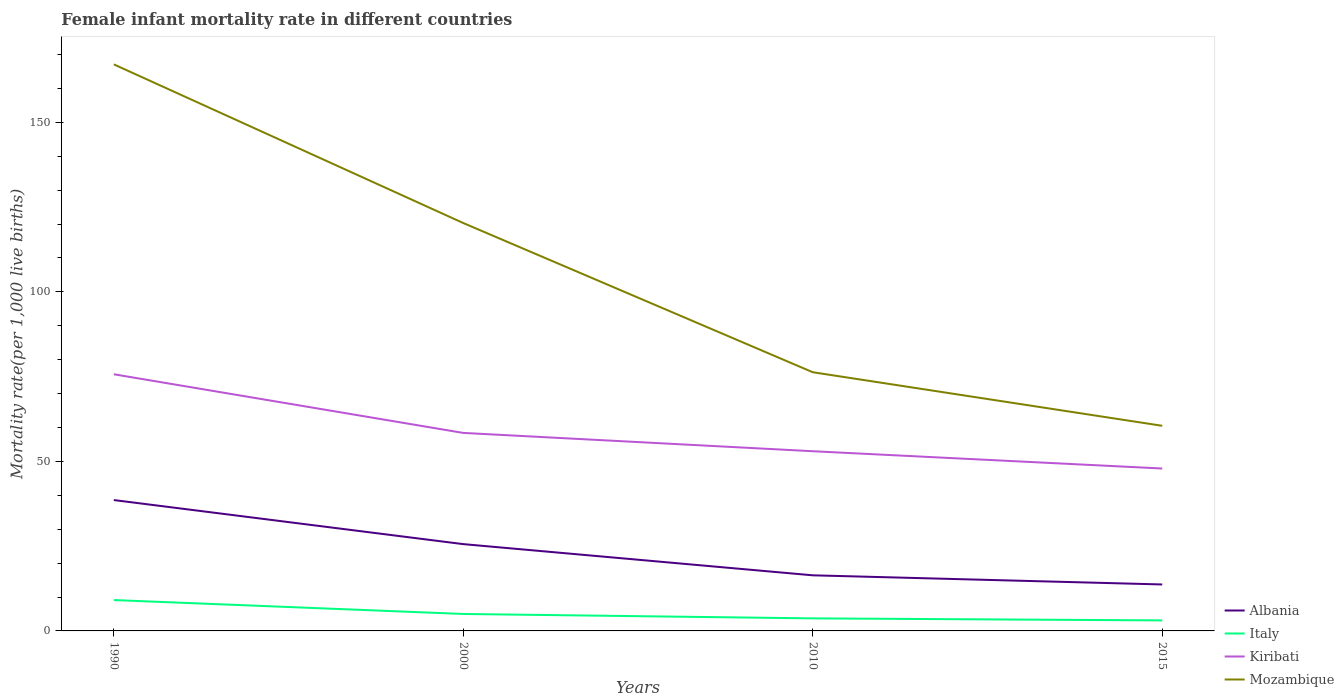How many different coloured lines are there?
Make the answer very short. 4. Does the line corresponding to Albania intersect with the line corresponding to Kiribati?
Offer a very short reply. No. Across all years, what is the maximum female infant mortality rate in Kiribati?
Keep it short and to the point. 47.9. In which year was the female infant mortality rate in Albania maximum?
Make the answer very short. 2015. What is the total female infant mortality rate in Mozambique in the graph?
Ensure brevity in your answer.  106.6. What is the difference between the highest and the second highest female infant mortality rate in Mozambique?
Offer a terse response. 106.6. What is the difference between the highest and the lowest female infant mortality rate in Mozambique?
Your answer should be compact. 2. Is the female infant mortality rate in Albania strictly greater than the female infant mortality rate in Kiribati over the years?
Your answer should be very brief. Yes. How many lines are there?
Make the answer very short. 4. What is the difference between two consecutive major ticks on the Y-axis?
Offer a terse response. 50. Does the graph contain any zero values?
Provide a succinct answer. No. How are the legend labels stacked?
Make the answer very short. Vertical. What is the title of the graph?
Your answer should be compact. Female infant mortality rate in different countries. Does "Sub-Saharan Africa (all income levels)" appear as one of the legend labels in the graph?
Your answer should be compact. No. What is the label or title of the Y-axis?
Make the answer very short. Mortality rate(per 1,0 live births). What is the Mortality rate(per 1,000 live births) of Albania in 1990?
Keep it short and to the point. 38.6. What is the Mortality rate(per 1,000 live births) of Kiribati in 1990?
Make the answer very short. 75.7. What is the Mortality rate(per 1,000 live births) in Mozambique in 1990?
Your answer should be very brief. 167.1. What is the Mortality rate(per 1,000 live births) in Albania in 2000?
Ensure brevity in your answer.  25.6. What is the Mortality rate(per 1,000 live births) of Italy in 2000?
Keep it short and to the point. 5. What is the Mortality rate(per 1,000 live births) in Kiribati in 2000?
Provide a short and direct response. 58.4. What is the Mortality rate(per 1,000 live births) of Mozambique in 2000?
Provide a short and direct response. 120.3. What is the Mortality rate(per 1,000 live births) in Albania in 2010?
Ensure brevity in your answer.  16.4. What is the Mortality rate(per 1,000 live births) of Mozambique in 2010?
Offer a very short reply. 76.3. What is the Mortality rate(per 1,000 live births) of Albania in 2015?
Make the answer very short. 13.7. What is the Mortality rate(per 1,000 live births) of Kiribati in 2015?
Provide a short and direct response. 47.9. What is the Mortality rate(per 1,000 live births) of Mozambique in 2015?
Provide a short and direct response. 60.5. Across all years, what is the maximum Mortality rate(per 1,000 live births) in Albania?
Provide a short and direct response. 38.6. Across all years, what is the maximum Mortality rate(per 1,000 live births) in Kiribati?
Make the answer very short. 75.7. Across all years, what is the maximum Mortality rate(per 1,000 live births) of Mozambique?
Keep it short and to the point. 167.1. Across all years, what is the minimum Mortality rate(per 1,000 live births) of Albania?
Give a very brief answer. 13.7. Across all years, what is the minimum Mortality rate(per 1,000 live births) of Kiribati?
Make the answer very short. 47.9. Across all years, what is the minimum Mortality rate(per 1,000 live births) of Mozambique?
Your response must be concise. 60.5. What is the total Mortality rate(per 1,000 live births) of Albania in the graph?
Offer a terse response. 94.3. What is the total Mortality rate(per 1,000 live births) of Italy in the graph?
Your response must be concise. 20.9. What is the total Mortality rate(per 1,000 live births) in Kiribati in the graph?
Your response must be concise. 235. What is the total Mortality rate(per 1,000 live births) in Mozambique in the graph?
Give a very brief answer. 424.2. What is the difference between the Mortality rate(per 1,000 live births) in Albania in 1990 and that in 2000?
Offer a terse response. 13. What is the difference between the Mortality rate(per 1,000 live births) in Kiribati in 1990 and that in 2000?
Ensure brevity in your answer.  17.3. What is the difference between the Mortality rate(per 1,000 live births) in Mozambique in 1990 and that in 2000?
Make the answer very short. 46.8. What is the difference between the Mortality rate(per 1,000 live births) in Italy in 1990 and that in 2010?
Your answer should be compact. 5.4. What is the difference between the Mortality rate(per 1,000 live births) in Kiribati in 1990 and that in 2010?
Offer a very short reply. 22.7. What is the difference between the Mortality rate(per 1,000 live births) in Mozambique in 1990 and that in 2010?
Your answer should be compact. 90.8. What is the difference between the Mortality rate(per 1,000 live births) in Albania in 1990 and that in 2015?
Provide a short and direct response. 24.9. What is the difference between the Mortality rate(per 1,000 live births) of Italy in 1990 and that in 2015?
Give a very brief answer. 6. What is the difference between the Mortality rate(per 1,000 live births) in Kiribati in 1990 and that in 2015?
Your answer should be compact. 27.8. What is the difference between the Mortality rate(per 1,000 live births) in Mozambique in 1990 and that in 2015?
Keep it short and to the point. 106.6. What is the difference between the Mortality rate(per 1,000 live births) of Kiribati in 2000 and that in 2010?
Ensure brevity in your answer.  5.4. What is the difference between the Mortality rate(per 1,000 live births) in Italy in 2000 and that in 2015?
Offer a very short reply. 1.9. What is the difference between the Mortality rate(per 1,000 live births) in Kiribati in 2000 and that in 2015?
Make the answer very short. 10.5. What is the difference between the Mortality rate(per 1,000 live births) in Mozambique in 2000 and that in 2015?
Provide a succinct answer. 59.8. What is the difference between the Mortality rate(per 1,000 live births) in Albania in 1990 and the Mortality rate(per 1,000 live births) in Italy in 2000?
Provide a short and direct response. 33.6. What is the difference between the Mortality rate(per 1,000 live births) of Albania in 1990 and the Mortality rate(per 1,000 live births) of Kiribati in 2000?
Your response must be concise. -19.8. What is the difference between the Mortality rate(per 1,000 live births) of Albania in 1990 and the Mortality rate(per 1,000 live births) of Mozambique in 2000?
Give a very brief answer. -81.7. What is the difference between the Mortality rate(per 1,000 live births) in Italy in 1990 and the Mortality rate(per 1,000 live births) in Kiribati in 2000?
Your answer should be compact. -49.3. What is the difference between the Mortality rate(per 1,000 live births) in Italy in 1990 and the Mortality rate(per 1,000 live births) in Mozambique in 2000?
Provide a succinct answer. -111.2. What is the difference between the Mortality rate(per 1,000 live births) of Kiribati in 1990 and the Mortality rate(per 1,000 live births) of Mozambique in 2000?
Provide a succinct answer. -44.6. What is the difference between the Mortality rate(per 1,000 live births) of Albania in 1990 and the Mortality rate(per 1,000 live births) of Italy in 2010?
Keep it short and to the point. 34.9. What is the difference between the Mortality rate(per 1,000 live births) of Albania in 1990 and the Mortality rate(per 1,000 live births) of Kiribati in 2010?
Your answer should be very brief. -14.4. What is the difference between the Mortality rate(per 1,000 live births) in Albania in 1990 and the Mortality rate(per 1,000 live births) in Mozambique in 2010?
Make the answer very short. -37.7. What is the difference between the Mortality rate(per 1,000 live births) of Italy in 1990 and the Mortality rate(per 1,000 live births) of Kiribati in 2010?
Provide a succinct answer. -43.9. What is the difference between the Mortality rate(per 1,000 live births) of Italy in 1990 and the Mortality rate(per 1,000 live births) of Mozambique in 2010?
Make the answer very short. -67.2. What is the difference between the Mortality rate(per 1,000 live births) of Albania in 1990 and the Mortality rate(per 1,000 live births) of Italy in 2015?
Provide a short and direct response. 35.5. What is the difference between the Mortality rate(per 1,000 live births) of Albania in 1990 and the Mortality rate(per 1,000 live births) of Mozambique in 2015?
Offer a terse response. -21.9. What is the difference between the Mortality rate(per 1,000 live births) in Italy in 1990 and the Mortality rate(per 1,000 live births) in Kiribati in 2015?
Give a very brief answer. -38.8. What is the difference between the Mortality rate(per 1,000 live births) of Italy in 1990 and the Mortality rate(per 1,000 live births) of Mozambique in 2015?
Offer a terse response. -51.4. What is the difference between the Mortality rate(per 1,000 live births) in Kiribati in 1990 and the Mortality rate(per 1,000 live births) in Mozambique in 2015?
Keep it short and to the point. 15.2. What is the difference between the Mortality rate(per 1,000 live births) in Albania in 2000 and the Mortality rate(per 1,000 live births) in Italy in 2010?
Provide a succinct answer. 21.9. What is the difference between the Mortality rate(per 1,000 live births) in Albania in 2000 and the Mortality rate(per 1,000 live births) in Kiribati in 2010?
Offer a terse response. -27.4. What is the difference between the Mortality rate(per 1,000 live births) of Albania in 2000 and the Mortality rate(per 1,000 live births) of Mozambique in 2010?
Your answer should be compact. -50.7. What is the difference between the Mortality rate(per 1,000 live births) in Italy in 2000 and the Mortality rate(per 1,000 live births) in Kiribati in 2010?
Keep it short and to the point. -48. What is the difference between the Mortality rate(per 1,000 live births) of Italy in 2000 and the Mortality rate(per 1,000 live births) of Mozambique in 2010?
Your answer should be very brief. -71.3. What is the difference between the Mortality rate(per 1,000 live births) in Kiribati in 2000 and the Mortality rate(per 1,000 live births) in Mozambique in 2010?
Provide a short and direct response. -17.9. What is the difference between the Mortality rate(per 1,000 live births) of Albania in 2000 and the Mortality rate(per 1,000 live births) of Kiribati in 2015?
Offer a very short reply. -22.3. What is the difference between the Mortality rate(per 1,000 live births) of Albania in 2000 and the Mortality rate(per 1,000 live births) of Mozambique in 2015?
Keep it short and to the point. -34.9. What is the difference between the Mortality rate(per 1,000 live births) of Italy in 2000 and the Mortality rate(per 1,000 live births) of Kiribati in 2015?
Ensure brevity in your answer.  -42.9. What is the difference between the Mortality rate(per 1,000 live births) of Italy in 2000 and the Mortality rate(per 1,000 live births) of Mozambique in 2015?
Your response must be concise. -55.5. What is the difference between the Mortality rate(per 1,000 live births) of Kiribati in 2000 and the Mortality rate(per 1,000 live births) of Mozambique in 2015?
Provide a short and direct response. -2.1. What is the difference between the Mortality rate(per 1,000 live births) of Albania in 2010 and the Mortality rate(per 1,000 live births) of Kiribati in 2015?
Offer a very short reply. -31.5. What is the difference between the Mortality rate(per 1,000 live births) in Albania in 2010 and the Mortality rate(per 1,000 live births) in Mozambique in 2015?
Make the answer very short. -44.1. What is the difference between the Mortality rate(per 1,000 live births) in Italy in 2010 and the Mortality rate(per 1,000 live births) in Kiribati in 2015?
Your answer should be compact. -44.2. What is the difference between the Mortality rate(per 1,000 live births) of Italy in 2010 and the Mortality rate(per 1,000 live births) of Mozambique in 2015?
Ensure brevity in your answer.  -56.8. What is the average Mortality rate(per 1,000 live births) in Albania per year?
Your answer should be very brief. 23.57. What is the average Mortality rate(per 1,000 live births) in Italy per year?
Offer a very short reply. 5.22. What is the average Mortality rate(per 1,000 live births) in Kiribati per year?
Offer a terse response. 58.75. What is the average Mortality rate(per 1,000 live births) of Mozambique per year?
Your answer should be compact. 106.05. In the year 1990, what is the difference between the Mortality rate(per 1,000 live births) of Albania and Mortality rate(per 1,000 live births) of Italy?
Offer a very short reply. 29.5. In the year 1990, what is the difference between the Mortality rate(per 1,000 live births) in Albania and Mortality rate(per 1,000 live births) in Kiribati?
Provide a succinct answer. -37.1. In the year 1990, what is the difference between the Mortality rate(per 1,000 live births) in Albania and Mortality rate(per 1,000 live births) in Mozambique?
Your response must be concise. -128.5. In the year 1990, what is the difference between the Mortality rate(per 1,000 live births) in Italy and Mortality rate(per 1,000 live births) in Kiribati?
Provide a short and direct response. -66.6. In the year 1990, what is the difference between the Mortality rate(per 1,000 live births) of Italy and Mortality rate(per 1,000 live births) of Mozambique?
Make the answer very short. -158. In the year 1990, what is the difference between the Mortality rate(per 1,000 live births) in Kiribati and Mortality rate(per 1,000 live births) in Mozambique?
Your response must be concise. -91.4. In the year 2000, what is the difference between the Mortality rate(per 1,000 live births) in Albania and Mortality rate(per 1,000 live births) in Italy?
Your response must be concise. 20.6. In the year 2000, what is the difference between the Mortality rate(per 1,000 live births) in Albania and Mortality rate(per 1,000 live births) in Kiribati?
Keep it short and to the point. -32.8. In the year 2000, what is the difference between the Mortality rate(per 1,000 live births) in Albania and Mortality rate(per 1,000 live births) in Mozambique?
Give a very brief answer. -94.7. In the year 2000, what is the difference between the Mortality rate(per 1,000 live births) in Italy and Mortality rate(per 1,000 live births) in Kiribati?
Give a very brief answer. -53.4. In the year 2000, what is the difference between the Mortality rate(per 1,000 live births) in Italy and Mortality rate(per 1,000 live births) in Mozambique?
Make the answer very short. -115.3. In the year 2000, what is the difference between the Mortality rate(per 1,000 live births) of Kiribati and Mortality rate(per 1,000 live births) of Mozambique?
Make the answer very short. -61.9. In the year 2010, what is the difference between the Mortality rate(per 1,000 live births) in Albania and Mortality rate(per 1,000 live births) in Italy?
Your answer should be compact. 12.7. In the year 2010, what is the difference between the Mortality rate(per 1,000 live births) in Albania and Mortality rate(per 1,000 live births) in Kiribati?
Your response must be concise. -36.6. In the year 2010, what is the difference between the Mortality rate(per 1,000 live births) in Albania and Mortality rate(per 1,000 live births) in Mozambique?
Ensure brevity in your answer.  -59.9. In the year 2010, what is the difference between the Mortality rate(per 1,000 live births) of Italy and Mortality rate(per 1,000 live births) of Kiribati?
Your answer should be compact. -49.3. In the year 2010, what is the difference between the Mortality rate(per 1,000 live births) in Italy and Mortality rate(per 1,000 live births) in Mozambique?
Provide a succinct answer. -72.6. In the year 2010, what is the difference between the Mortality rate(per 1,000 live births) in Kiribati and Mortality rate(per 1,000 live births) in Mozambique?
Your answer should be very brief. -23.3. In the year 2015, what is the difference between the Mortality rate(per 1,000 live births) of Albania and Mortality rate(per 1,000 live births) of Kiribati?
Give a very brief answer. -34.2. In the year 2015, what is the difference between the Mortality rate(per 1,000 live births) of Albania and Mortality rate(per 1,000 live births) of Mozambique?
Give a very brief answer. -46.8. In the year 2015, what is the difference between the Mortality rate(per 1,000 live births) in Italy and Mortality rate(per 1,000 live births) in Kiribati?
Your answer should be compact. -44.8. In the year 2015, what is the difference between the Mortality rate(per 1,000 live births) of Italy and Mortality rate(per 1,000 live births) of Mozambique?
Your answer should be compact. -57.4. What is the ratio of the Mortality rate(per 1,000 live births) in Albania in 1990 to that in 2000?
Offer a terse response. 1.51. What is the ratio of the Mortality rate(per 1,000 live births) in Italy in 1990 to that in 2000?
Offer a terse response. 1.82. What is the ratio of the Mortality rate(per 1,000 live births) in Kiribati in 1990 to that in 2000?
Your response must be concise. 1.3. What is the ratio of the Mortality rate(per 1,000 live births) of Mozambique in 1990 to that in 2000?
Offer a terse response. 1.39. What is the ratio of the Mortality rate(per 1,000 live births) of Albania in 1990 to that in 2010?
Give a very brief answer. 2.35. What is the ratio of the Mortality rate(per 1,000 live births) in Italy in 1990 to that in 2010?
Keep it short and to the point. 2.46. What is the ratio of the Mortality rate(per 1,000 live births) of Kiribati in 1990 to that in 2010?
Offer a terse response. 1.43. What is the ratio of the Mortality rate(per 1,000 live births) in Mozambique in 1990 to that in 2010?
Your answer should be very brief. 2.19. What is the ratio of the Mortality rate(per 1,000 live births) of Albania in 1990 to that in 2015?
Make the answer very short. 2.82. What is the ratio of the Mortality rate(per 1,000 live births) in Italy in 1990 to that in 2015?
Give a very brief answer. 2.94. What is the ratio of the Mortality rate(per 1,000 live births) of Kiribati in 1990 to that in 2015?
Ensure brevity in your answer.  1.58. What is the ratio of the Mortality rate(per 1,000 live births) in Mozambique in 1990 to that in 2015?
Your answer should be compact. 2.76. What is the ratio of the Mortality rate(per 1,000 live births) in Albania in 2000 to that in 2010?
Provide a short and direct response. 1.56. What is the ratio of the Mortality rate(per 1,000 live births) in Italy in 2000 to that in 2010?
Make the answer very short. 1.35. What is the ratio of the Mortality rate(per 1,000 live births) in Kiribati in 2000 to that in 2010?
Your answer should be very brief. 1.1. What is the ratio of the Mortality rate(per 1,000 live births) of Mozambique in 2000 to that in 2010?
Make the answer very short. 1.58. What is the ratio of the Mortality rate(per 1,000 live births) of Albania in 2000 to that in 2015?
Ensure brevity in your answer.  1.87. What is the ratio of the Mortality rate(per 1,000 live births) in Italy in 2000 to that in 2015?
Ensure brevity in your answer.  1.61. What is the ratio of the Mortality rate(per 1,000 live births) of Kiribati in 2000 to that in 2015?
Ensure brevity in your answer.  1.22. What is the ratio of the Mortality rate(per 1,000 live births) of Mozambique in 2000 to that in 2015?
Provide a succinct answer. 1.99. What is the ratio of the Mortality rate(per 1,000 live births) in Albania in 2010 to that in 2015?
Make the answer very short. 1.2. What is the ratio of the Mortality rate(per 1,000 live births) in Italy in 2010 to that in 2015?
Keep it short and to the point. 1.19. What is the ratio of the Mortality rate(per 1,000 live births) of Kiribati in 2010 to that in 2015?
Offer a terse response. 1.11. What is the ratio of the Mortality rate(per 1,000 live births) of Mozambique in 2010 to that in 2015?
Your answer should be very brief. 1.26. What is the difference between the highest and the second highest Mortality rate(per 1,000 live births) of Italy?
Ensure brevity in your answer.  4.1. What is the difference between the highest and the second highest Mortality rate(per 1,000 live births) of Mozambique?
Your response must be concise. 46.8. What is the difference between the highest and the lowest Mortality rate(per 1,000 live births) in Albania?
Give a very brief answer. 24.9. What is the difference between the highest and the lowest Mortality rate(per 1,000 live births) of Kiribati?
Offer a terse response. 27.8. What is the difference between the highest and the lowest Mortality rate(per 1,000 live births) in Mozambique?
Keep it short and to the point. 106.6. 